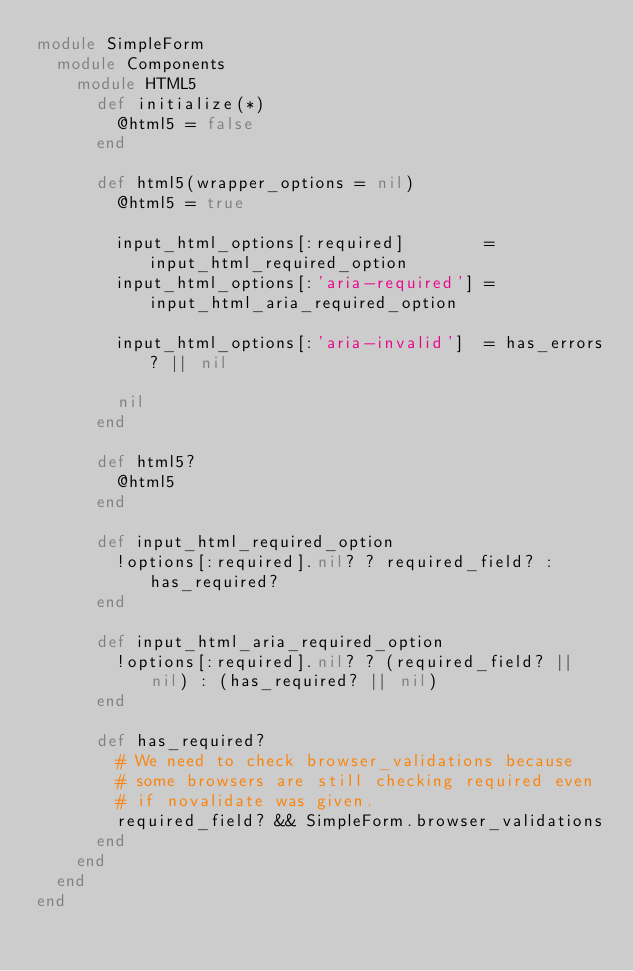<code> <loc_0><loc_0><loc_500><loc_500><_Ruby_>module SimpleForm
  module Components
    module HTML5
      def initialize(*)
        @html5 = false
      end

      def html5(wrapper_options = nil)
        @html5 = true

        input_html_options[:required]        = input_html_required_option
        input_html_options[:'aria-required'] = input_html_aria_required_option

        input_html_options[:'aria-invalid']  = has_errors? || nil

        nil
      end

      def html5?
        @html5
      end

      def input_html_required_option
        !options[:required].nil? ? required_field? : has_required?
      end

      def input_html_aria_required_option
        !options[:required].nil? ? (required_field? || nil) : (has_required? || nil)
      end

      def has_required?
        # We need to check browser_validations because
        # some browsers are still checking required even
        # if novalidate was given.
        required_field? && SimpleForm.browser_validations
      end
    end
  end
end
</code> 